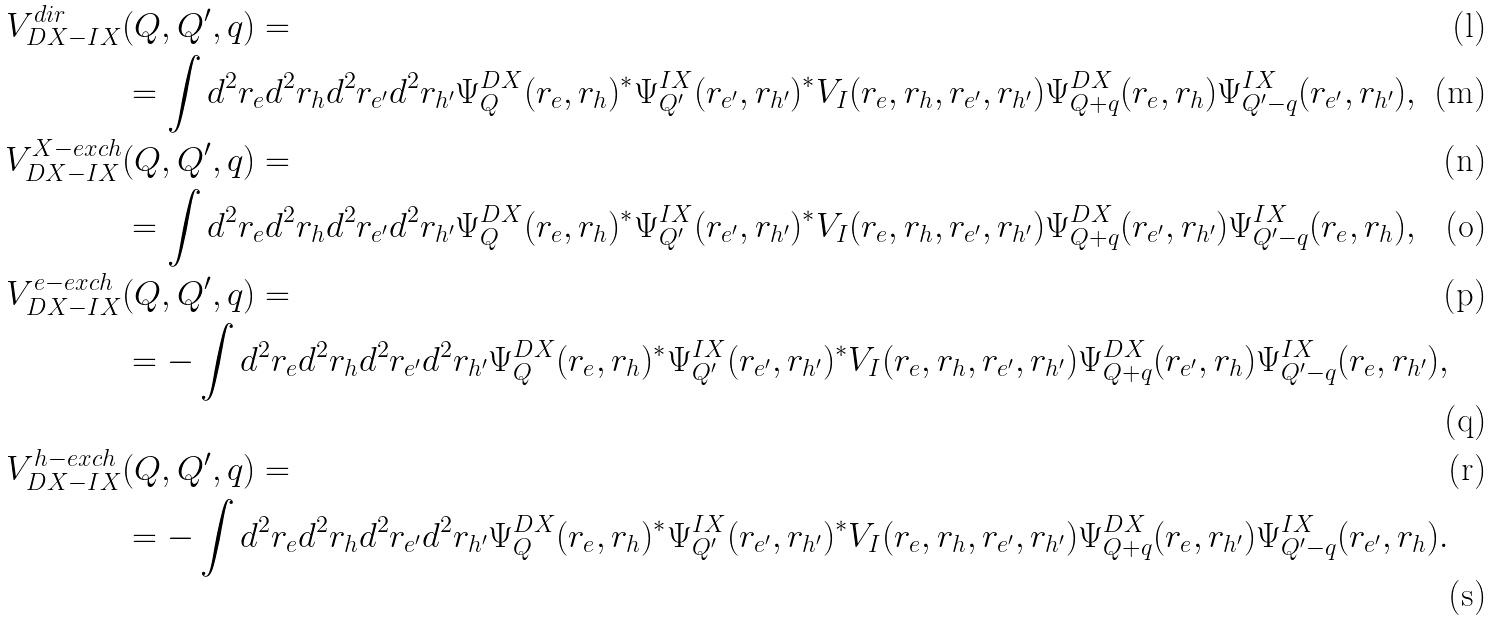<formula> <loc_0><loc_0><loc_500><loc_500>V _ { D X - I X } ^ { d i r } & ( Q , Q ^ { \prime } , q ) = \\ & = \int d ^ { 2 } r _ { e } d ^ { 2 } r _ { h } d ^ { 2 } r _ { e ^ { \prime } } d ^ { 2 } r _ { h ^ { \prime } } \Psi ^ { D X } _ { Q } ( r _ { e } , r _ { h } ) ^ { \ast } \Psi ^ { I X } _ { Q ^ { \prime } } ( r _ { e ^ { \prime } } , r _ { h ^ { \prime } } ) ^ { \ast } V _ { I } ( r _ { e } , r _ { h } , r _ { e ^ { \prime } } , r _ { h ^ { \prime } } ) \Psi ^ { D X } _ { Q + q } ( r _ { e } , r _ { h } ) \Psi ^ { I X } _ { Q ^ { \prime } - q } ( r _ { e ^ { \prime } } , r _ { h ^ { \prime } } ) , \\ V _ { D X - I X } ^ { X - e x c h } & ( Q , Q ^ { \prime } , q ) = \\ & = \int d ^ { 2 } r _ { e } d ^ { 2 } r _ { h } d ^ { 2 } r _ { e ^ { \prime } } d ^ { 2 } r _ { h ^ { \prime } } \Psi ^ { D X } _ { Q } ( r _ { e } , r _ { h } ) ^ { \ast } \Psi ^ { I X } _ { Q ^ { \prime } } ( r _ { e ^ { \prime } } , r _ { h ^ { \prime } } ) ^ { \ast } V _ { I } ( r _ { e } , r _ { h } , r _ { e ^ { \prime } } , r _ { h ^ { \prime } } ) \Psi ^ { D X } _ { Q + q } ( r _ { e ^ { \prime } } , r _ { h ^ { \prime } } ) \Psi ^ { I X } _ { Q ^ { \prime } - q } ( r _ { e } , r _ { h } ) , \\ V _ { D X - I X } ^ { e - e x c h } & ( Q , Q ^ { \prime } , q ) = \\ & = - \int d ^ { 2 } r _ { e } d ^ { 2 } r _ { h } d ^ { 2 } r _ { e ^ { \prime } } d ^ { 2 } r _ { h ^ { \prime } } \Psi ^ { D X } _ { Q } ( r _ { e } , r _ { h } ) ^ { \ast } \Psi ^ { I X } _ { Q ^ { \prime } } ( r _ { e ^ { \prime } } , r _ { h ^ { \prime } } ) ^ { \ast } V _ { I } ( r _ { e } , r _ { h } , r _ { e ^ { \prime } } , r _ { h ^ { \prime } } ) \Psi ^ { D X } _ { Q + q } ( r _ { e ^ { \prime } } , r _ { h } ) \Psi ^ { I X } _ { Q ^ { \prime } - q } ( r _ { e } , r _ { h ^ { \prime } } ) , \\ V _ { D X - I X } ^ { h - e x c h } & ( Q , Q ^ { \prime } , q ) = \\ & = - \int d ^ { 2 } r _ { e } d ^ { 2 } r _ { h } d ^ { 2 } r _ { e ^ { \prime } } d ^ { 2 } r _ { h ^ { \prime } } \Psi ^ { D X } _ { Q } ( r _ { e } , r _ { h } ) ^ { \ast } \Psi ^ { I X } _ { Q ^ { \prime } } ( r _ { e ^ { \prime } } , r _ { h ^ { \prime } } ) ^ { \ast } V _ { I } ( r _ { e } , r _ { h } , r _ { e ^ { \prime } } , r _ { h ^ { \prime } } ) \Psi ^ { D X } _ { Q + q } ( r _ { e } , r _ { h ^ { \prime } } ) \Psi ^ { I X } _ { Q ^ { \prime } - q } ( r _ { e ^ { \prime } } , r _ { h } ) .</formula> 